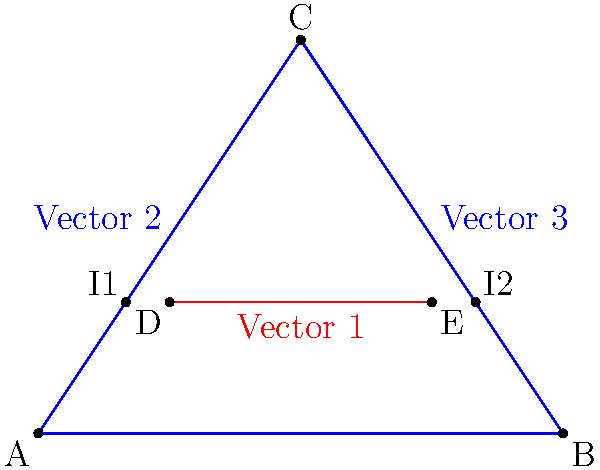In designing a Teen Titans cosplay outfit, you're creating an intricate pattern using vector paths. Two blue vectors form a triangle, and a red vector intersects them as shown. If the coordinates of points A, B, C, D, and E are A(0,0), B(4,0), C(2,3), D(1,1), and E(3,1) respectively, what is the total length of the red vector segment between its intersection points with the blue vectors (I1 and I2)? To solve this problem, we'll follow these steps:

1. Find the equations of the lines AC, BC, and DE.
2. Calculate the intersection points I1 and I2.
3. Compute the distance between I1 and I2.

Step 1: Line equations
- Line AC: $y = \frac{3}{2}x$
- Line BC: $y = -\frac{3}{2}x + 6$
- Line DE: $y = 1$

Step 2: Intersection points
- I1 (intersection of AC and DE):
  $1 = \frac{3}{2}x$
  $x = \frac{2}{3}$, $y = 1$
  I1 $(\frac{2}{3}, 1)$

- I2 (intersection of BC and DE):
  $1 = -\frac{3}{2}x + 6$
  $x = \frac{10}{3}$, $y = 1$
  I2 $(\frac{10}{3}, 1)$

Step 3: Distance between I1 and I2
Using the distance formula:
$d = \sqrt{(x_2-x_1)^2 + (y_2-y_1)^2}$
$d = \sqrt{(\frac{10}{3} - \frac{2}{3})^2 + (1-1)^2}$
$d = \sqrt{(\frac{8}{3})^2} = \frac{8}{3}$

Therefore, the length of the red vector segment between I1 and I2 is $\frac{8}{3}$ units.
Answer: $\frac{8}{3}$ units 